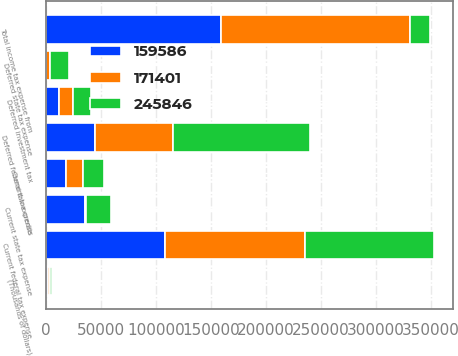Convert chart to OTSL. <chart><loc_0><loc_0><loc_500><loc_500><stacked_bar_chart><ecel><fcel>(Thousands of dollars)<fcel>Current federal tax expense<fcel>Current state tax expense<fcel>Current tax credits<fcel>Deferred federal tax expense<fcel>Deferred state tax expense<fcel>Deferred investment tax<fcel>Total income tax expense from<nl><fcel>159586<fcel>2004<fcel>108857<fcel>35733<fcel>18303<fcel>45172<fcel>316<fcel>12189<fcel>159586<nl><fcel>171401<fcel>2003<fcel>126828<fcel>1170<fcel>15268<fcel>70153<fcel>3298<fcel>12440<fcel>171401<nl><fcel>245846<fcel>2002<fcel>117430<fcel>22149<fcel>19079<fcel>124537<fcel>17435<fcel>16626<fcel>18303<nl></chart> 